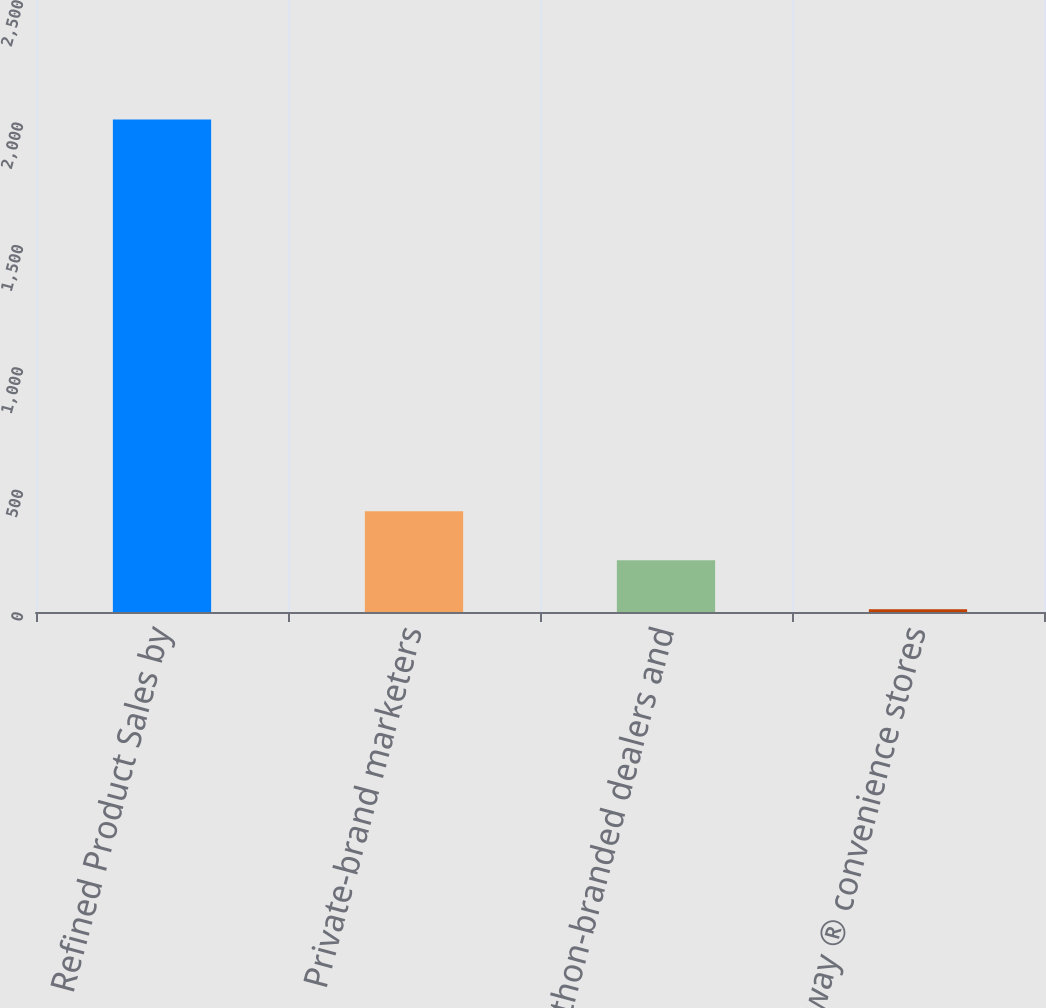Convert chart. <chart><loc_0><loc_0><loc_500><loc_500><bar_chart><fcel>Refined Product Sales by<fcel>Private-brand marketers<fcel>Marathon-branded dealers and<fcel>Speedway ® convenience stores<nl><fcel>2012<fcel>411.2<fcel>211.1<fcel>11<nl></chart> 